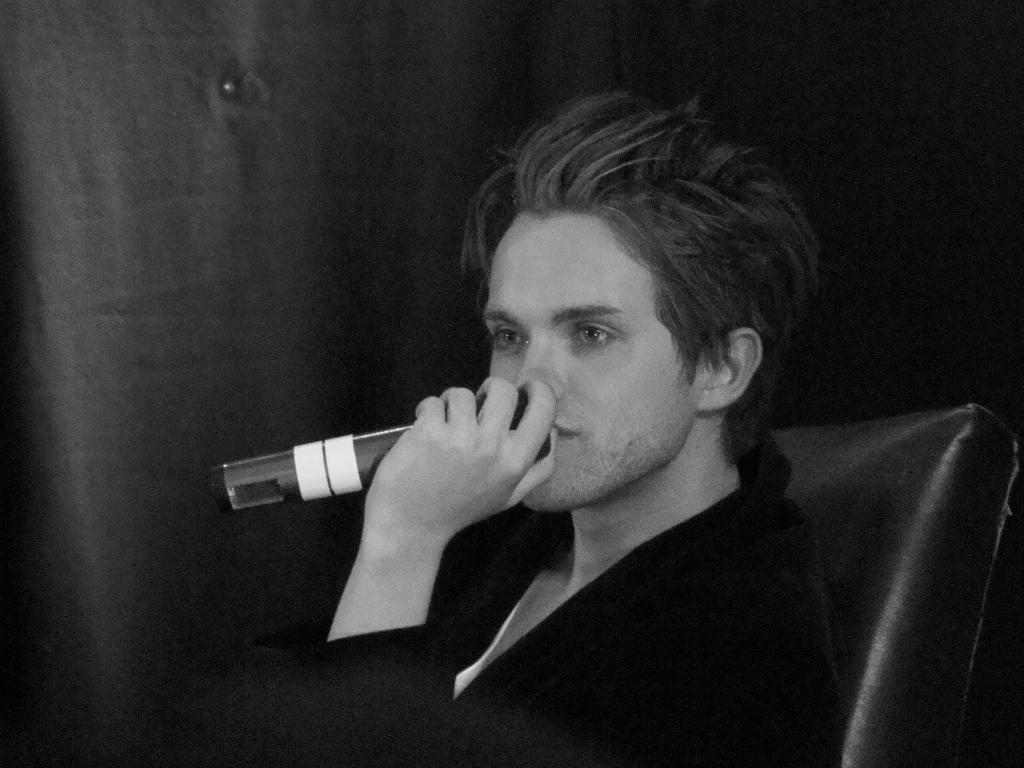Who or what is the main subject in the image? There is a person in the image. What is the person holding in the image? The person is holding a microphone. What is the person's position in the image? The person is sitting on a chair. What type of goat can be seen in the image? There is no goat present in the image; it features a person holding a microphone and sitting on a chair. 